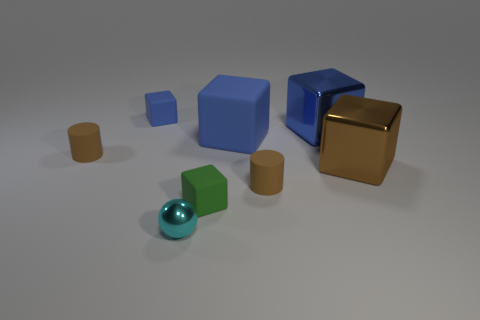Is the big brown shiny object the same shape as the large blue shiny thing?
Offer a very short reply. Yes. What is the size of the shiny block that is the same color as the big rubber block?
Offer a very short reply. Large. There is a rubber cube in front of the large brown metallic cube; what number of brown objects are to the left of it?
Make the answer very short. 1. How many tiny things are in front of the big blue rubber cube and on the left side of the big blue rubber object?
Ensure brevity in your answer.  3. How many objects are either yellow matte balls or small rubber objects on the right side of the cyan sphere?
Your answer should be compact. 2. There is a block that is made of the same material as the large brown thing; what size is it?
Make the answer very short. Large. There is a tiny brown matte thing that is right of the big matte cube to the left of the brown block; what shape is it?
Ensure brevity in your answer.  Cylinder. How many green objects are metal balls or shiny cubes?
Your answer should be compact. 0. There is a small brown rubber cylinder in front of the rubber cylinder on the left side of the small cyan shiny sphere; are there any brown objects that are on the right side of it?
Keep it short and to the point. Yes. The big metallic object that is the same color as the large rubber thing is what shape?
Offer a terse response. Cube. 